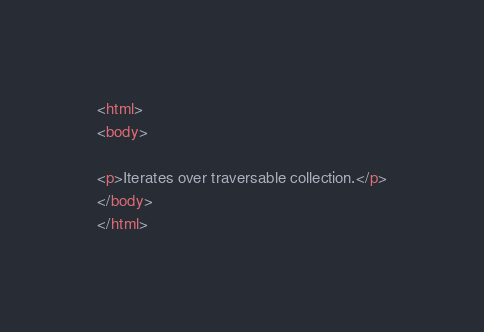<code> <loc_0><loc_0><loc_500><loc_500><_HTML_><html>
<body>

<p>Iterates over traversable collection.</p>
</body>
</html>
</code> 